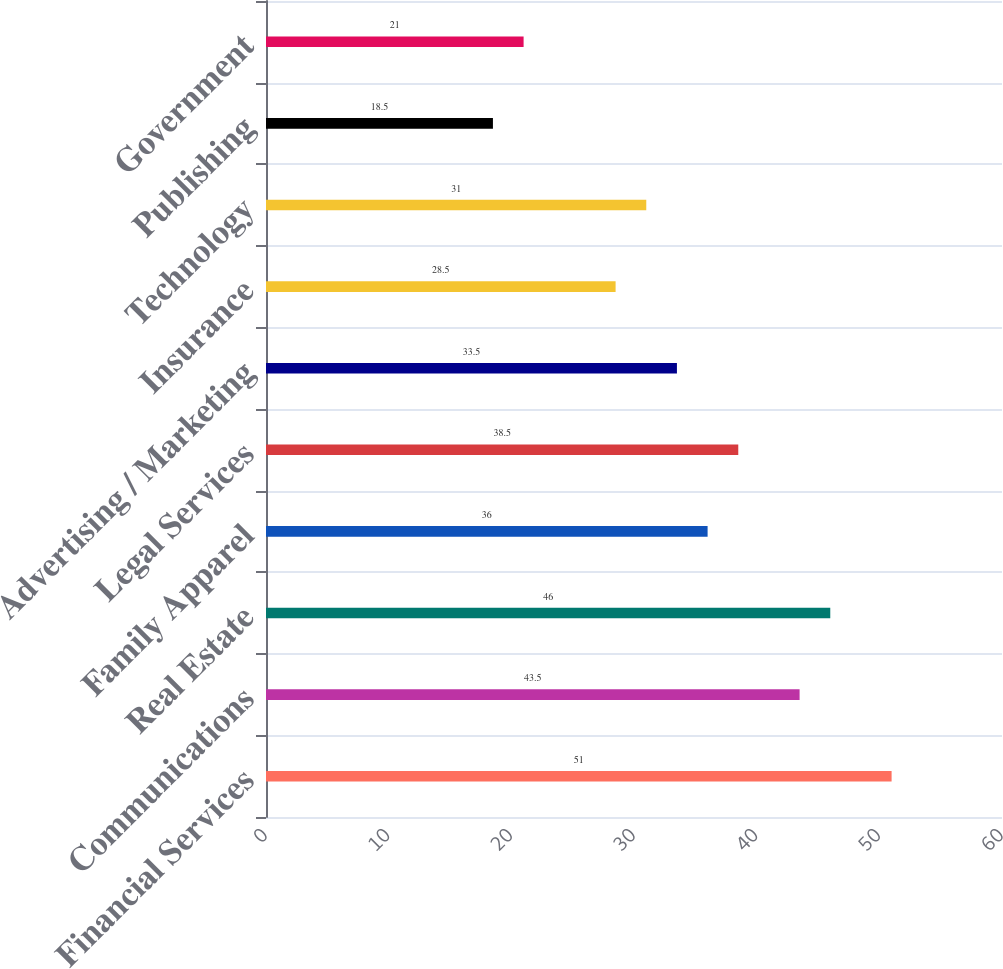Convert chart. <chart><loc_0><loc_0><loc_500><loc_500><bar_chart><fcel>Financial Services<fcel>Communications<fcel>Real Estate<fcel>Family Apparel<fcel>Legal Services<fcel>Advertising / Marketing<fcel>Insurance<fcel>Technology<fcel>Publishing<fcel>Government<nl><fcel>51<fcel>43.5<fcel>46<fcel>36<fcel>38.5<fcel>33.5<fcel>28.5<fcel>31<fcel>18.5<fcel>21<nl></chart> 